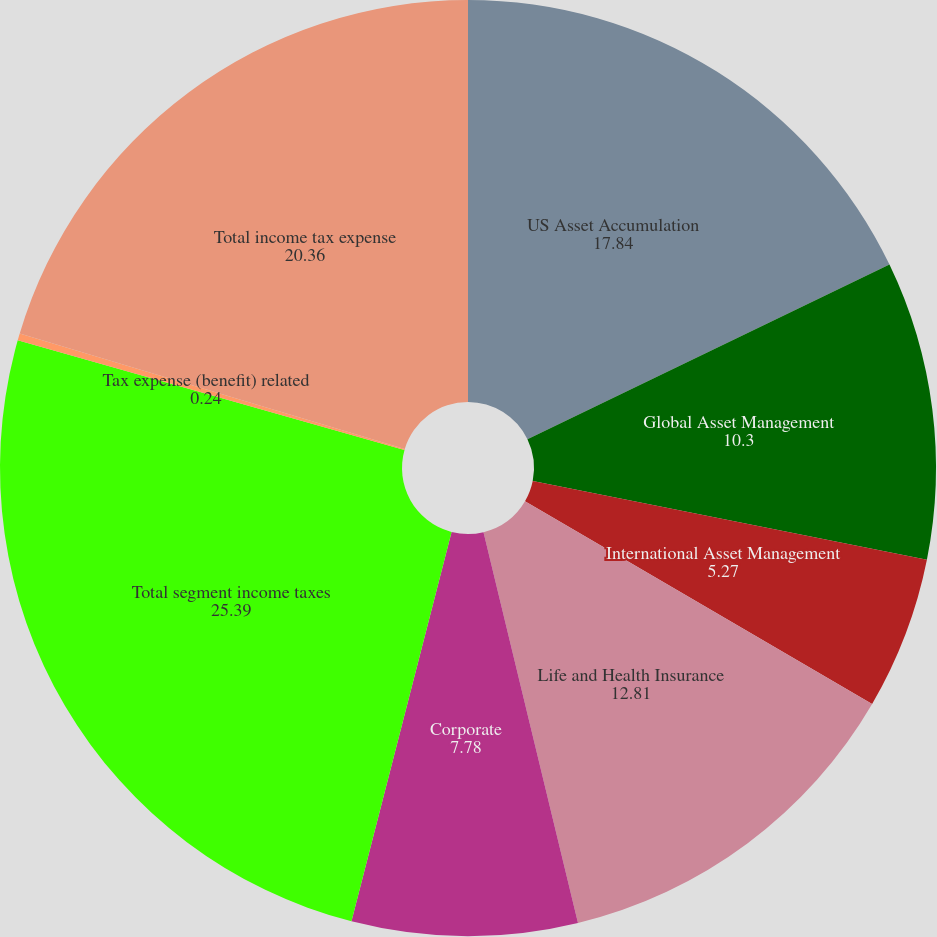Convert chart to OTSL. <chart><loc_0><loc_0><loc_500><loc_500><pie_chart><fcel>US Asset Accumulation<fcel>Global Asset Management<fcel>International Asset Management<fcel>Life and Health Insurance<fcel>Corporate<fcel>Total segment income taxes<fcel>Tax expense (benefit) related<fcel>Total income tax expense<nl><fcel>17.84%<fcel>10.3%<fcel>5.27%<fcel>12.81%<fcel>7.78%<fcel>25.39%<fcel>0.24%<fcel>20.36%<nl></chart> 